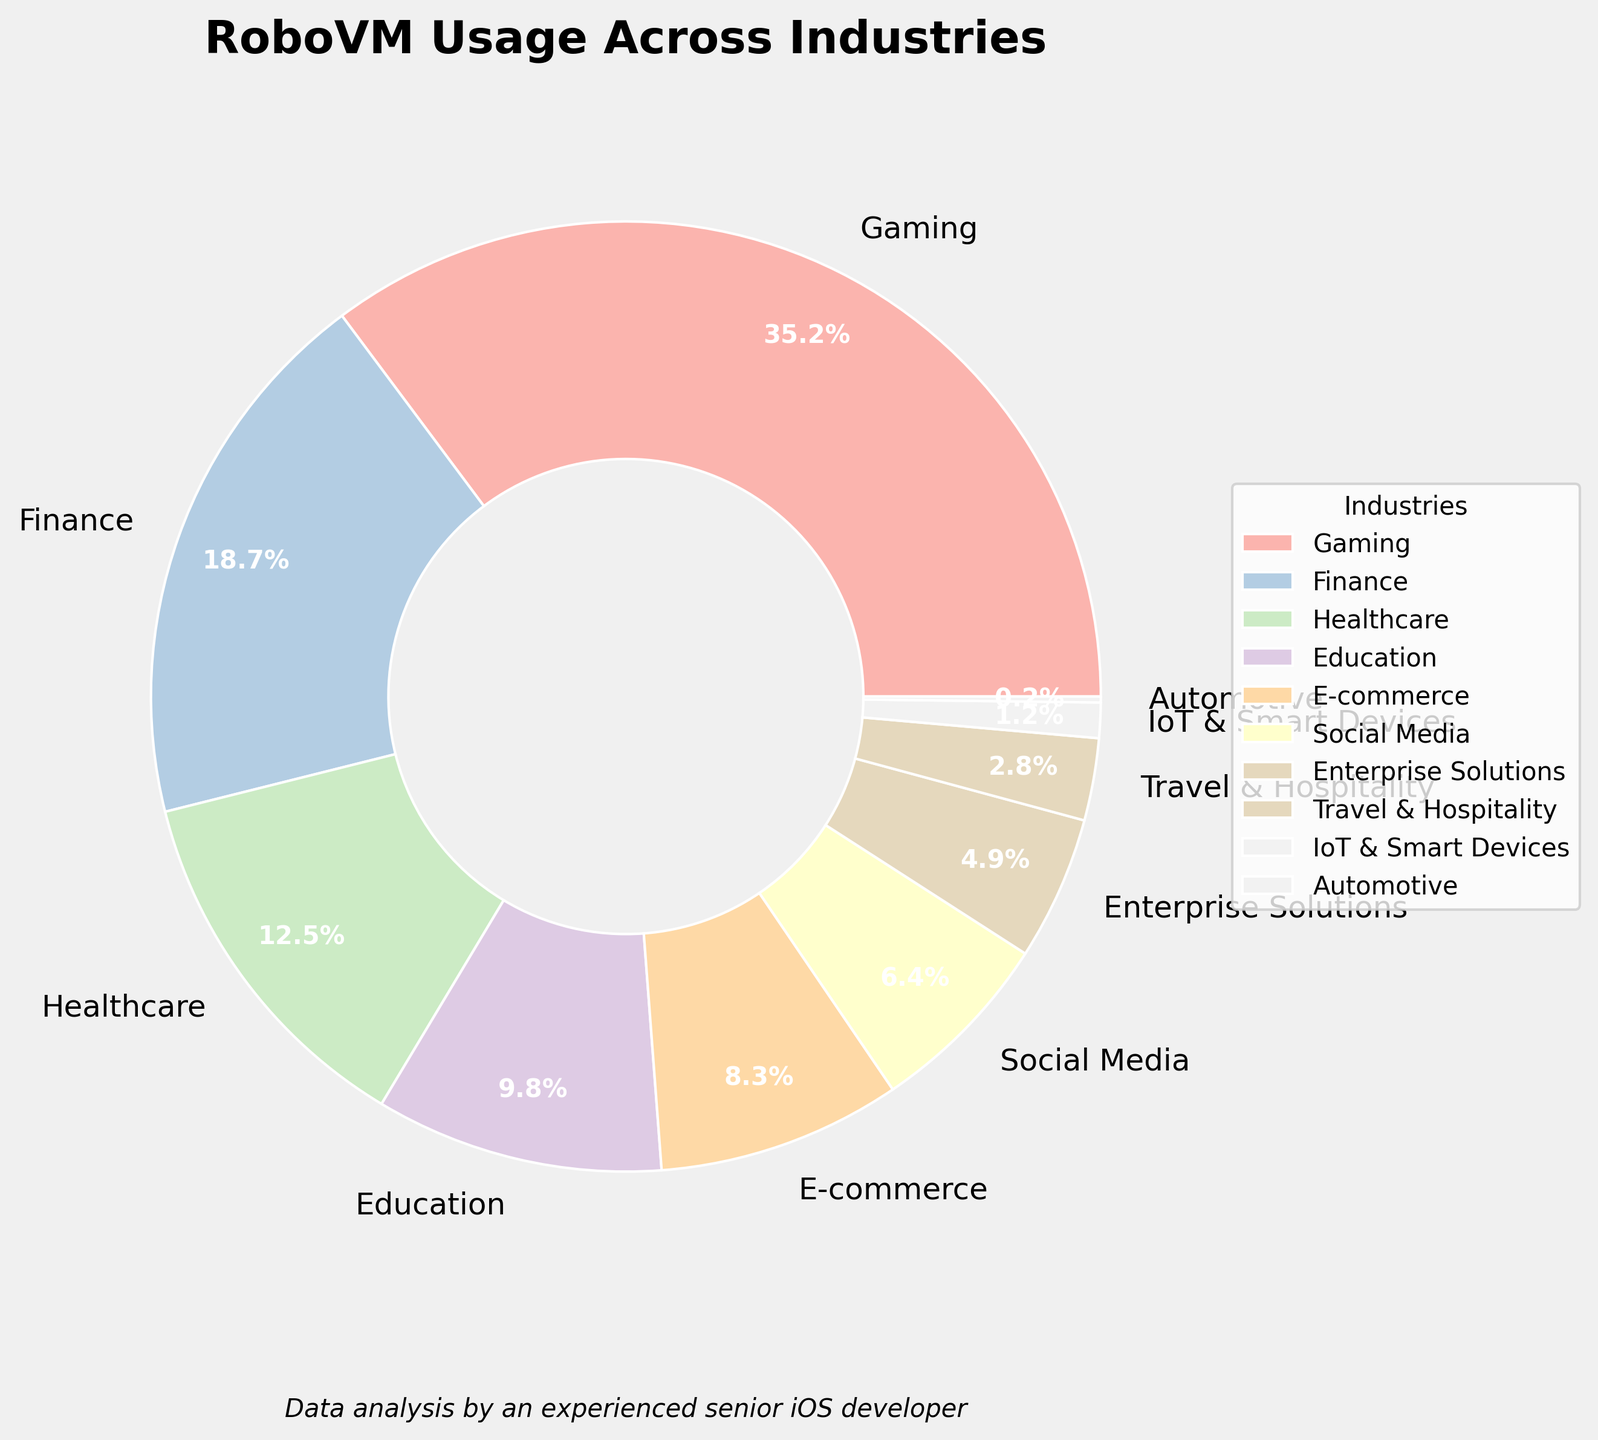What industry has the highest usage percentage of RoboVM? By looking at the pie chart, the segment corresponding to "Gaming" is the largest. The label indicates "Gaming" has 35.2% usage.
Answer: Gaming Which industries have usage percentages greater than 10%? By examining the pie chart, the segments indicating usage percentages greater than 10% are "Gaming" (35.2%), "Finance" (18.7%), and "Healthcare" (12.5%).
Answer: Gaming, Finance, Healthcare What is the combined percentage of RoboVM usage in "Social Media" and "E-commerce"? According to the pie chart, "Social Media" has 6.4% and "E-commerce" has 8.3%. Summing these values gives 6.4% + 8.3% = 14.7%.
Answer: 14.7% Is RoboVM usage in "Travel & Hospitality" less than that in "Enterprise Solutions"? From the pie chart, "Travel & Hospitality" has 2.8% and "Enterprise Solutions" has 4.9%. Since 2.8% is less than 4.9%, RoboVM usage in "Travel & Hospitality" is indeed less.
Answer: Yes Which industry has the smallest usage percentage of RoboVM? Observing the pie chart, the smallest segment corresponds to the "Automotive" industry, with a usage percentage of 0.2%.
Answer: Automotive What is the difference in usage percentage between "Finance" and "Healthcare"? "Finance" has 18.7%, and "Healthcare" has 12.5%. The difference can be calculated as 18.7% - 12.5% = 6.2%.
Answer: 6.2% What is the combined percentage of the smallest three industry segments? The smallest segments are "Automotive" (0.2%), "IoT & Smart Devices" (1.2%), and "Travel & Hospitality" (2.8%). Summing these gives 0.2% + 1.2% + 2.8% = 4.2%.
Answer: 4.2% How many industry segments have usage percentages below 10%? From the pie chart, these segments are: "Education" (9.8%), "E-commerce" (8.3%), "Social Media" (6.4%), "Enterprise Solutions" (4.9%), "Travel & Hospitality" (2.8%), "IoT & Smart Devices" (1.2%), and "Automotive" (0.2%). Counting these gives seven segments.
Answer: 7 